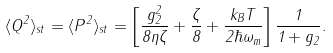Convert formula to latex. <formula><loc_0><loc_0><loc_500><loc_500>\langle Q ^ { 2 } \rangle _ { s t } = \langle P ^ { 2 } \rangle _ { s t } = \left [ \frac { g _ { 2 } ^ { 2 } } { 8 \eta \zeta } + \frac { \zeta } { 8 } + \frac { k _ { B } T } { 2 \hbar { \omega } _ { m } } \right ] \frac { 1 } { 1 + g _ { 2 } } .</formula> 